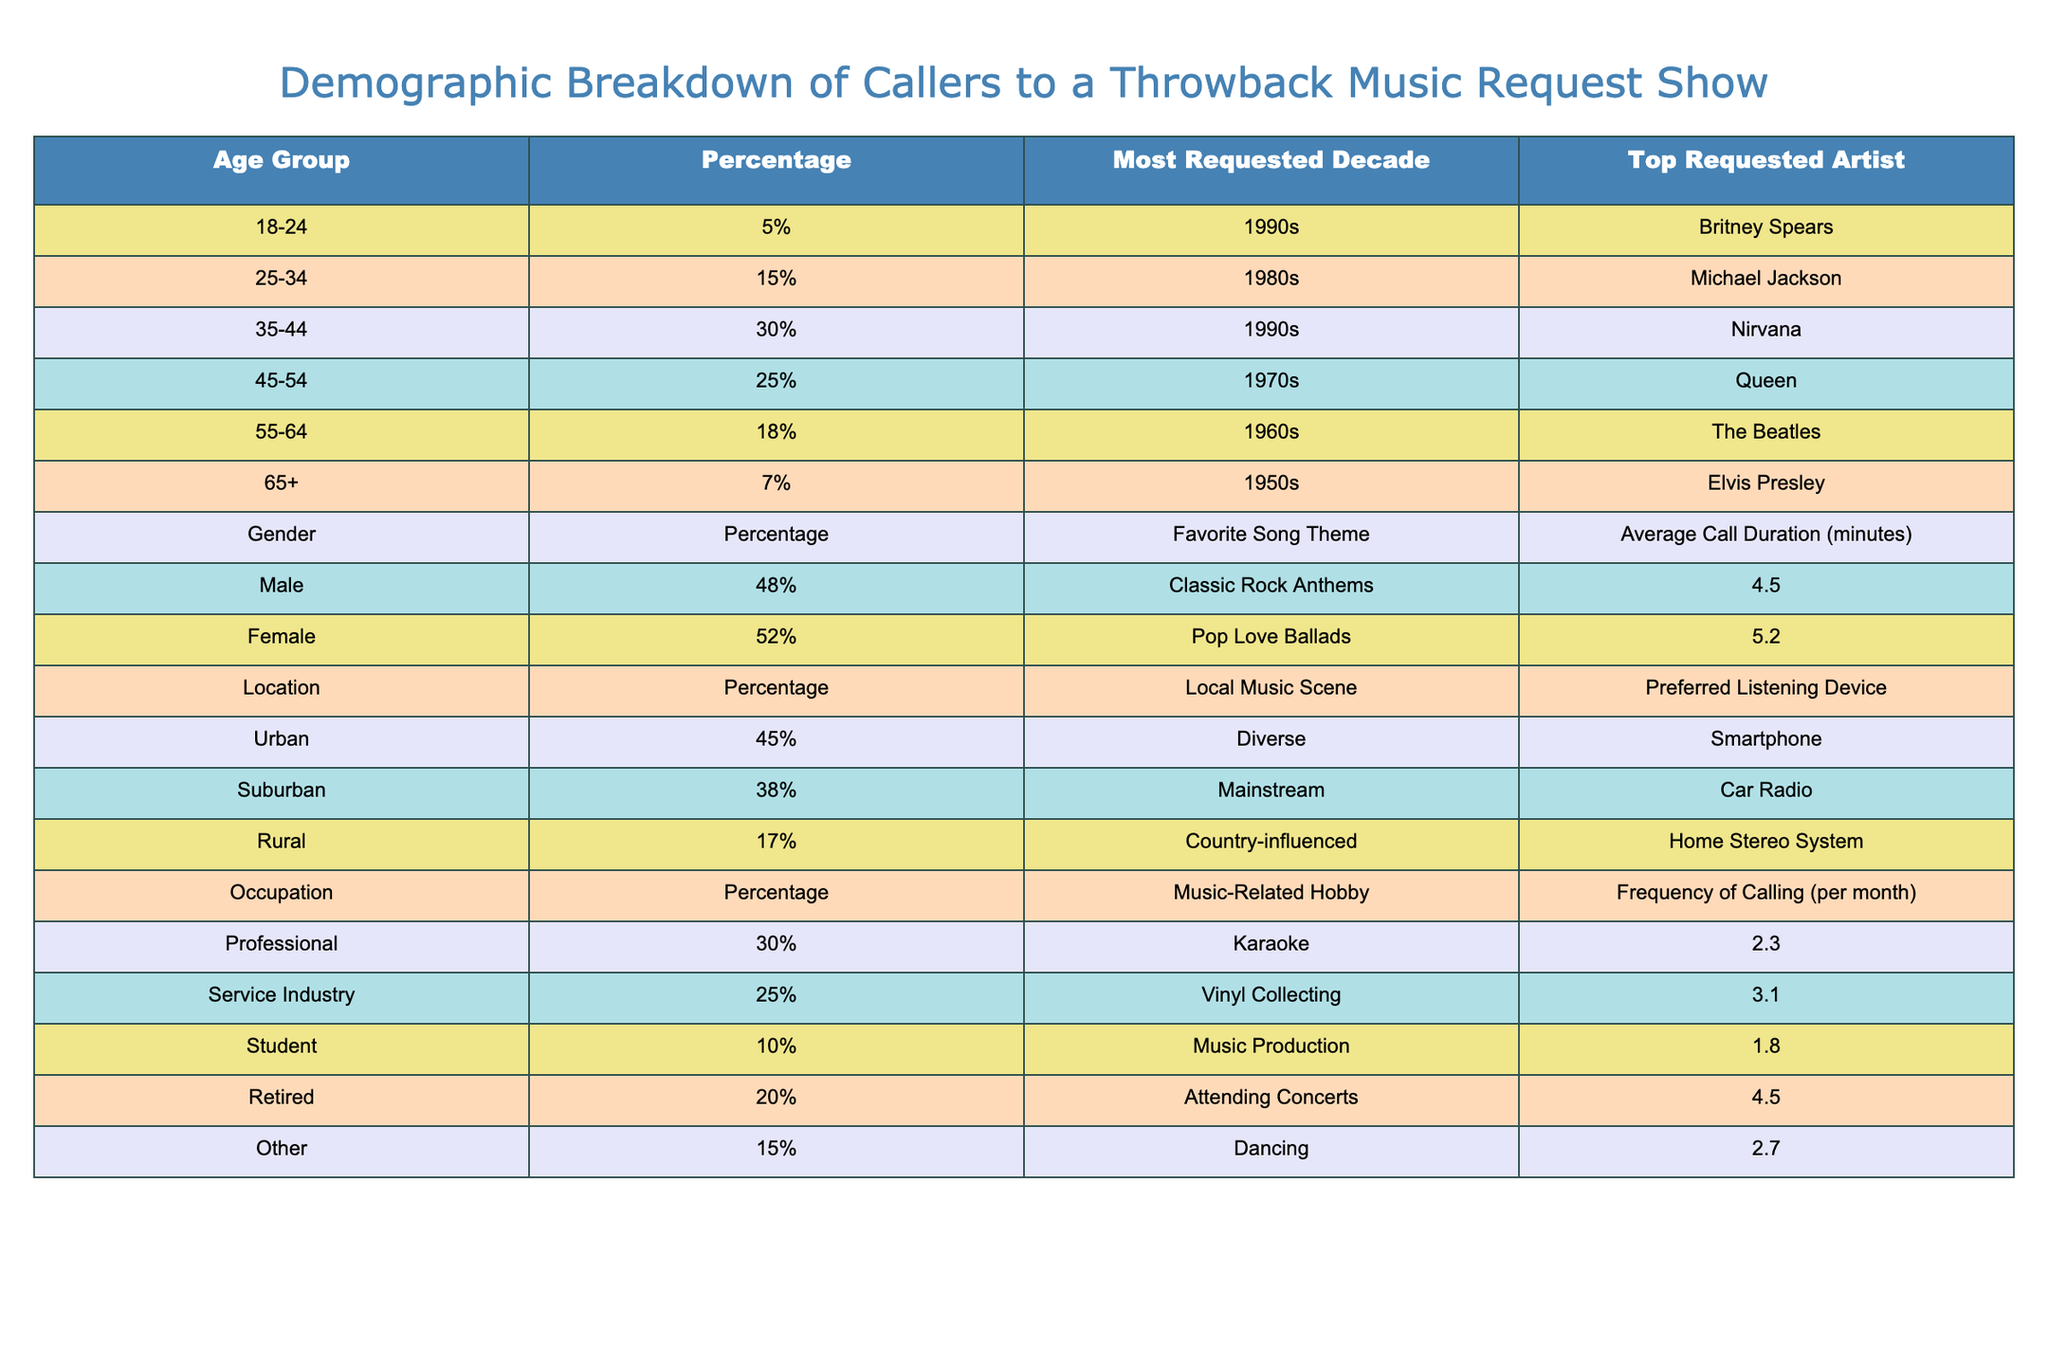What percentage of callers are aged 35-44? The table indicates that 30% of callers belong to the 35-44 age group.
Answer: 30% Which age group has the highest percentage of callers? From the table, the age group 35-44 has the highest percentage at 30%.
Answer: 35-44 What is the most requested decade among callers aged 55-64? According to the table, the most requested decade for the 55-64 age group is the 1960s.
Answer: 1960s Do more male or female callers request songs in the show? The table shows that 52% of callers are female, while 48% are male, indicating more female callers.
Answer: Female Which occupation has the highest frequency of calling per month? The table reveals that the Service Industry has an average calling frequency of 3.1 calls per month, which is the highest among all occupations listed.
Answer: Service Industry What is the average call duration for male callers? The table states that the average call duration for male callers is 4.5 minutes.
Answer: 4.5 minutes What percentage of callers are located in urban areas? According to the table, 45% of callers are from urban areas.
Answer: 45% If you sum the percentages of callers aged 45-54 and 65+, what is the total percentage? Adding the percentages of these two groups gives 25% (45-54) + 7% (65+) = 32%.
Answer: 32% Is the favorite song theme for females related to pop? The table indicates that the favorite song theme for females is "Pop Love Ballads," so the answer is yes.
Answer: Yes Which demographic has the most requested artist from the 1970s? Based on the table, the age group 45-54 has the top requested artist from the 1970s, which is Queen.
Answer: 45-54 What is the preferred listening device for rural callers? The table shows that the preferred listening device for rural callers is the home stereo system.
Answer: Home Stereo System 